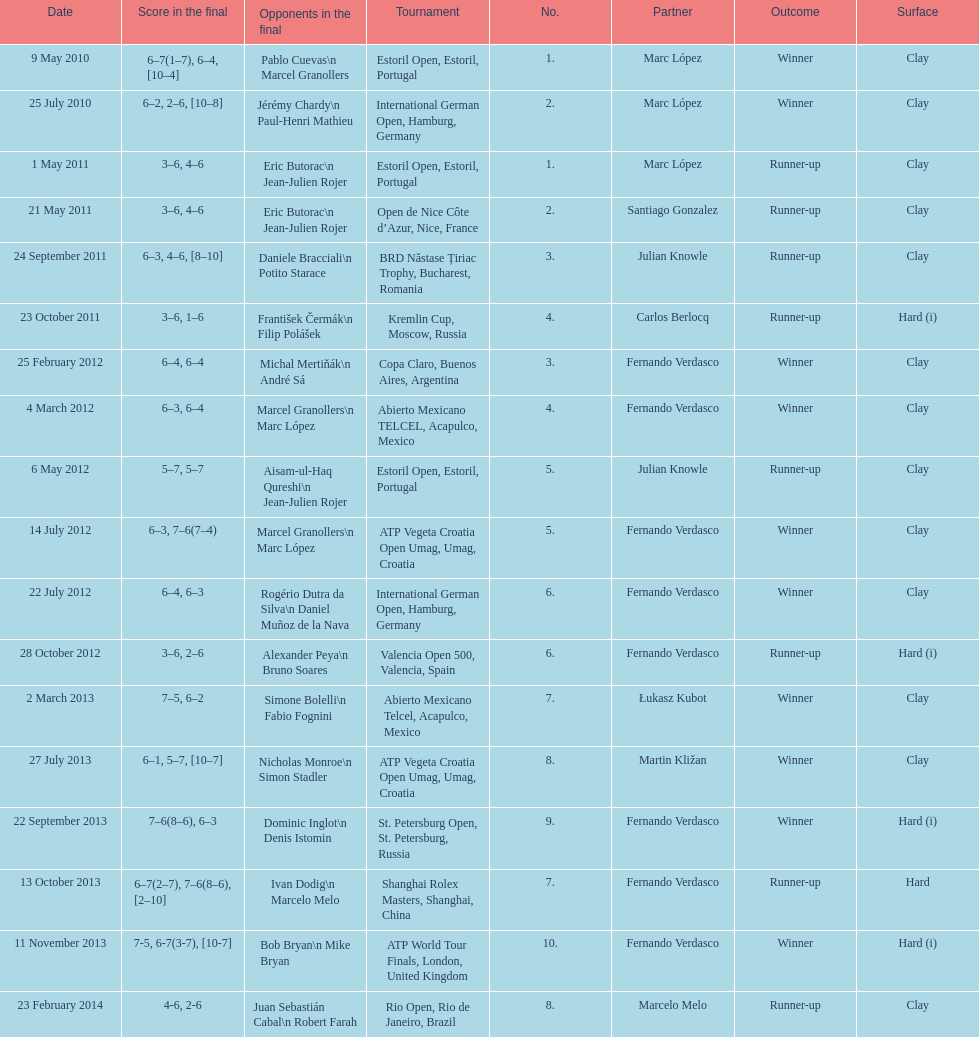How many tournaments has this player won in his career so far? 10. 